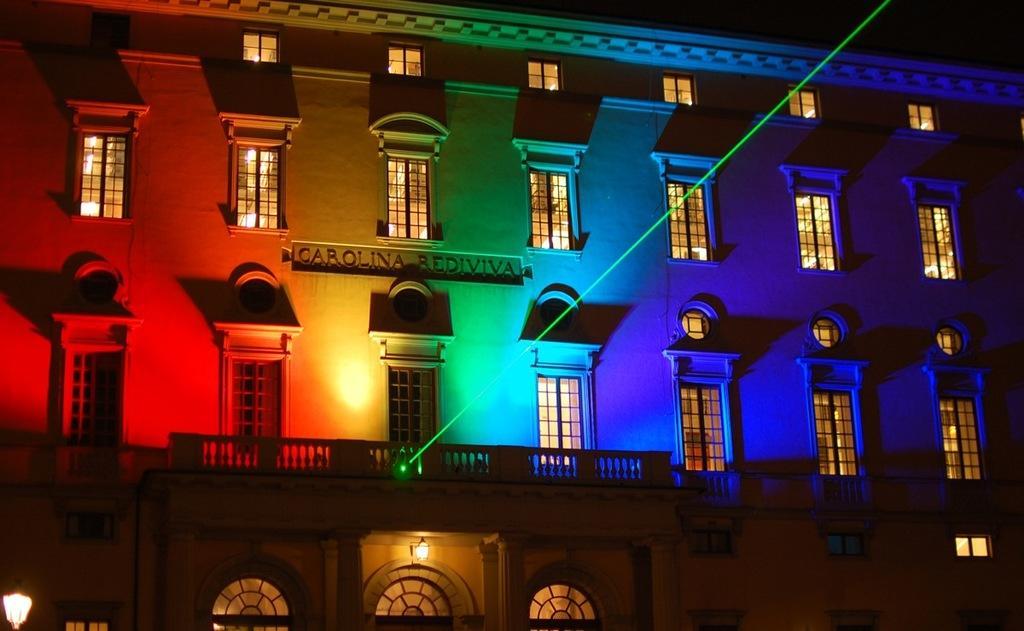In one or two sentences, can you explain what this image depicts? In this image I can see the building. There are many windows and railing to the building. I can also see the lights attached to the building. And there is a black background. 